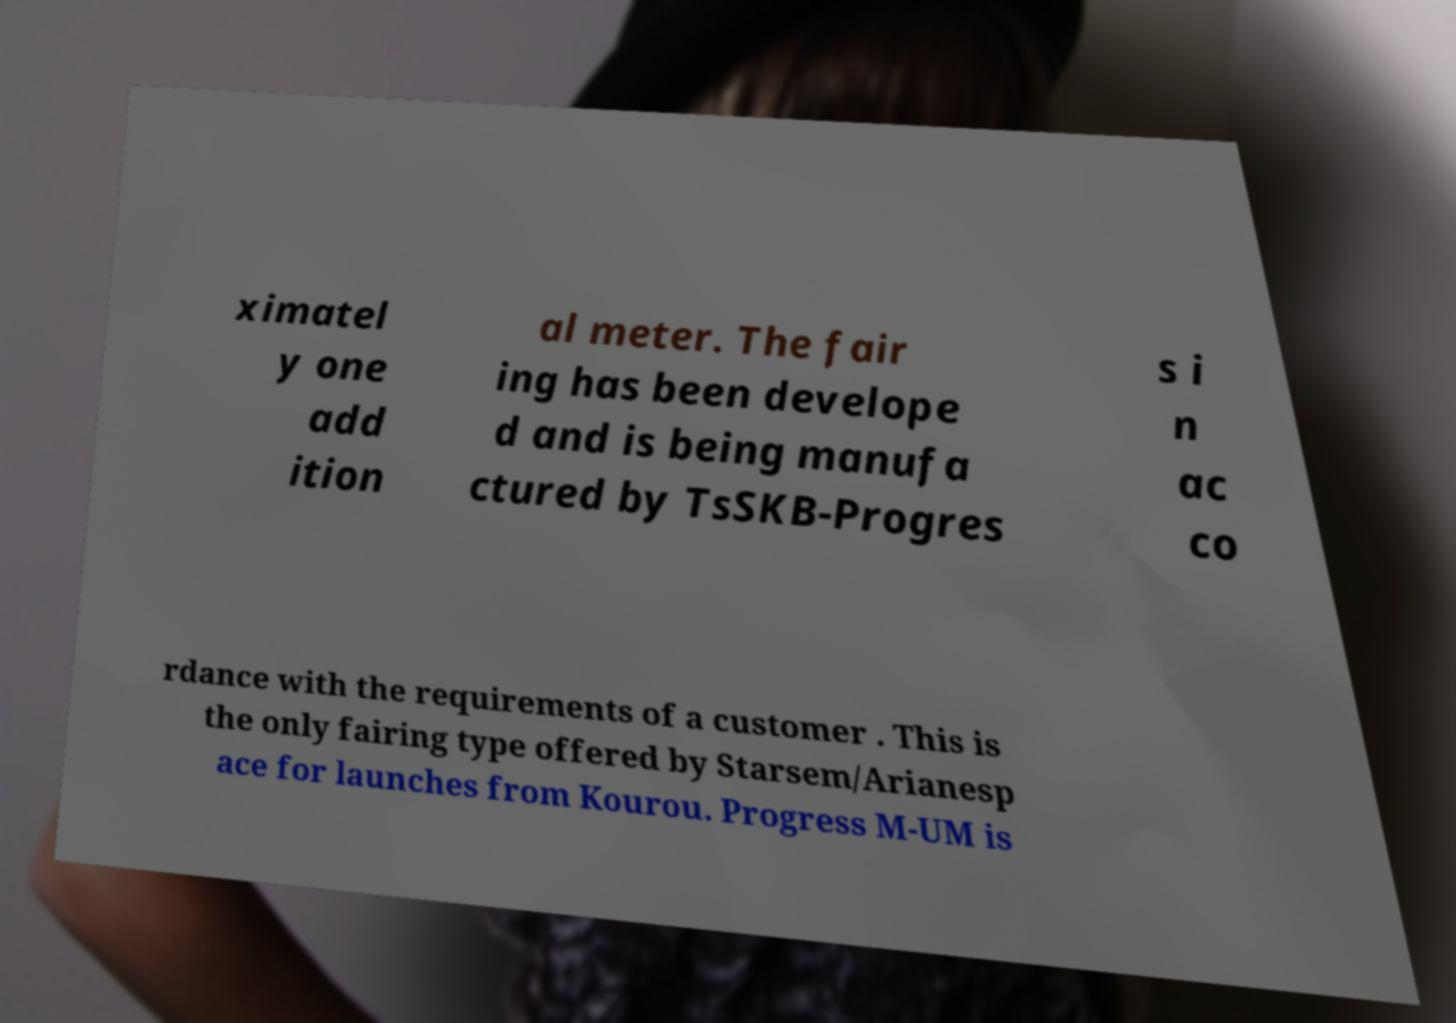Can you read and provide the text displayed in the image?This photo seems to have some interesting text. Can you extract and type it out for me? ximatel y one add ition al meter. The fair ing has been develope d and is being manufa ctured by TsSKB-Progres s i n ac co rdance with the requirements of a customer . This is the only fairing type offered by Starsem/Arianesp ace for launches from Kourou. Progress M-UM is 